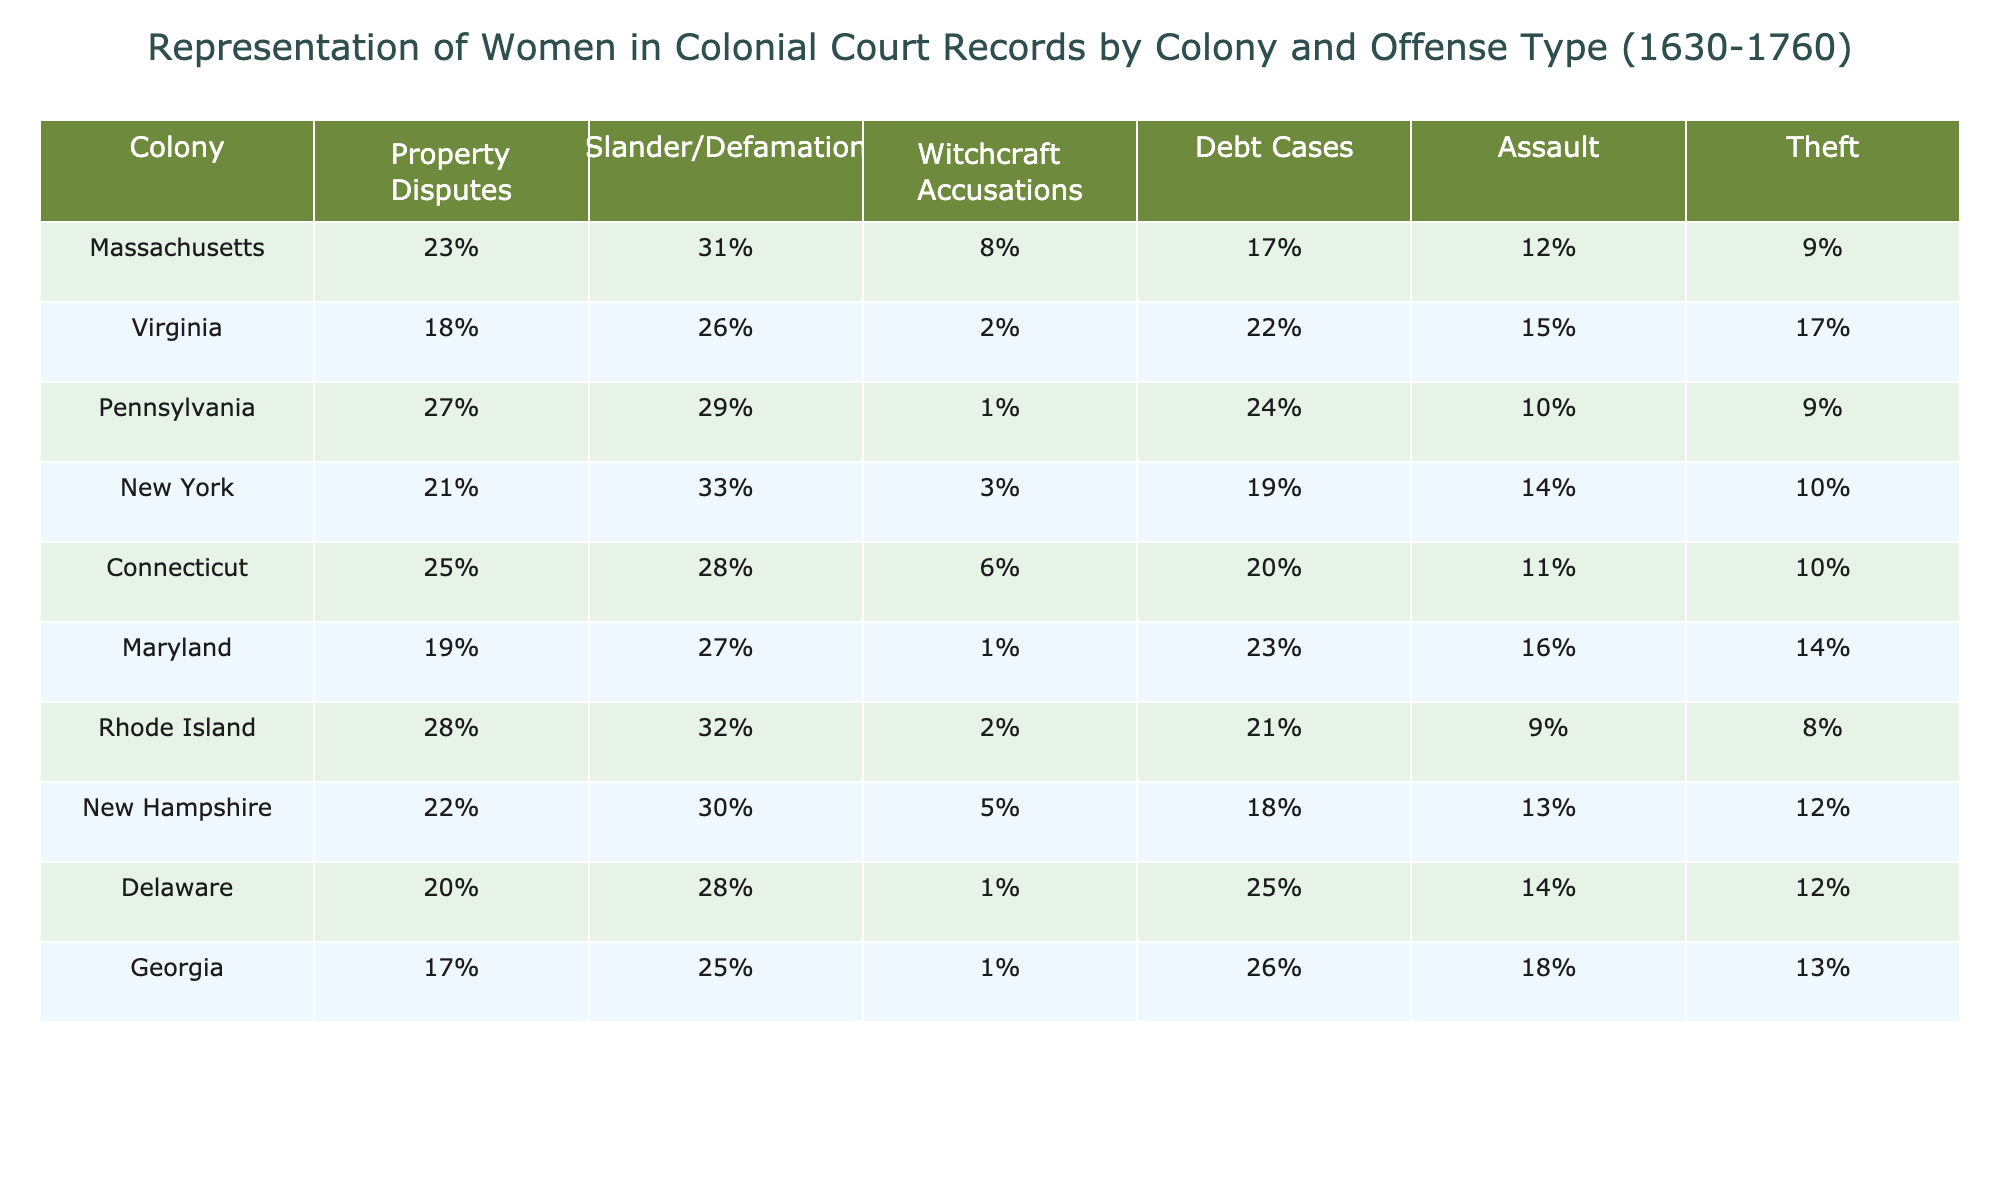What colony has the highest percentage of women involved in property disputes? In the table, Massachusetts shows the highest percentage of women involved in property disputes at 23%.
Answer: Massachusetts Which colony has the lowest percentage of women accused of witchcraft? The lowest percentage of women accused of witchcraft is found in Pennsylvania, at 1%.
Answer: Pennsylvania What is the average percentage of women involved in debt cases across all colonies? Adding the percentages for debt cases: (17 + 22 + 24 + 19 + 20 + 23 + 21 + 18 + 25 + 26) =  25.4, and dividing by 10 colonies gives an average of 25.4%.
Answer: 25.4% Is the percentage of women accused of slander higher in New York or Virginia? New York has 33% compared to Virginia's 26%, so slander accusations are higher in New York.
Answer: New York Which colony has the second-highest percentage of women involved in assault cases? New Hampshire has 13%, which is the second-highest after Georgia with 18%.
Answer: New Hampshire What is the difference in the percentage of women involved in theft between the highest and lowest colonies? Rhode Island has the lowest percentage at 8% and the highest is Virginia at 17%. The difference is 17% - 8% = 9%.
Answer: 9% Are more women involved in slander/defamation cases or in assault cases in Connecticut? In Connecticut, the percentage for slander/defamation is 28%, while for assault it is 11%. More women are involved in slander/defamation.
Answer: Yes Which colony shows the highest percentage of women accused of theft and what is that percentage? Georgia has the highest percentage of women involved in theft at 17%.
Answer: Georgia, 17% If you compare the percentages of property disputes in Massachusetts and Pennsylvania, which is greater and by how much? Massachusetts has 23% and Pennsylvania has 27%. Pennsylvania's percentage is greater by 27% - 23% = 4%.
Answer: 4% What is the total percentage of women involved in assault cases across all colonies? The sum of the percentages of women involved in assault cases across all colonies is (12 + 15 + 10 + 14 + 11 + 16 + 9 + 13 + 14 + 18) =  148%, and dividing by the number of colonies (10) gives an average of 14.8%.
Answer: 14.8% 